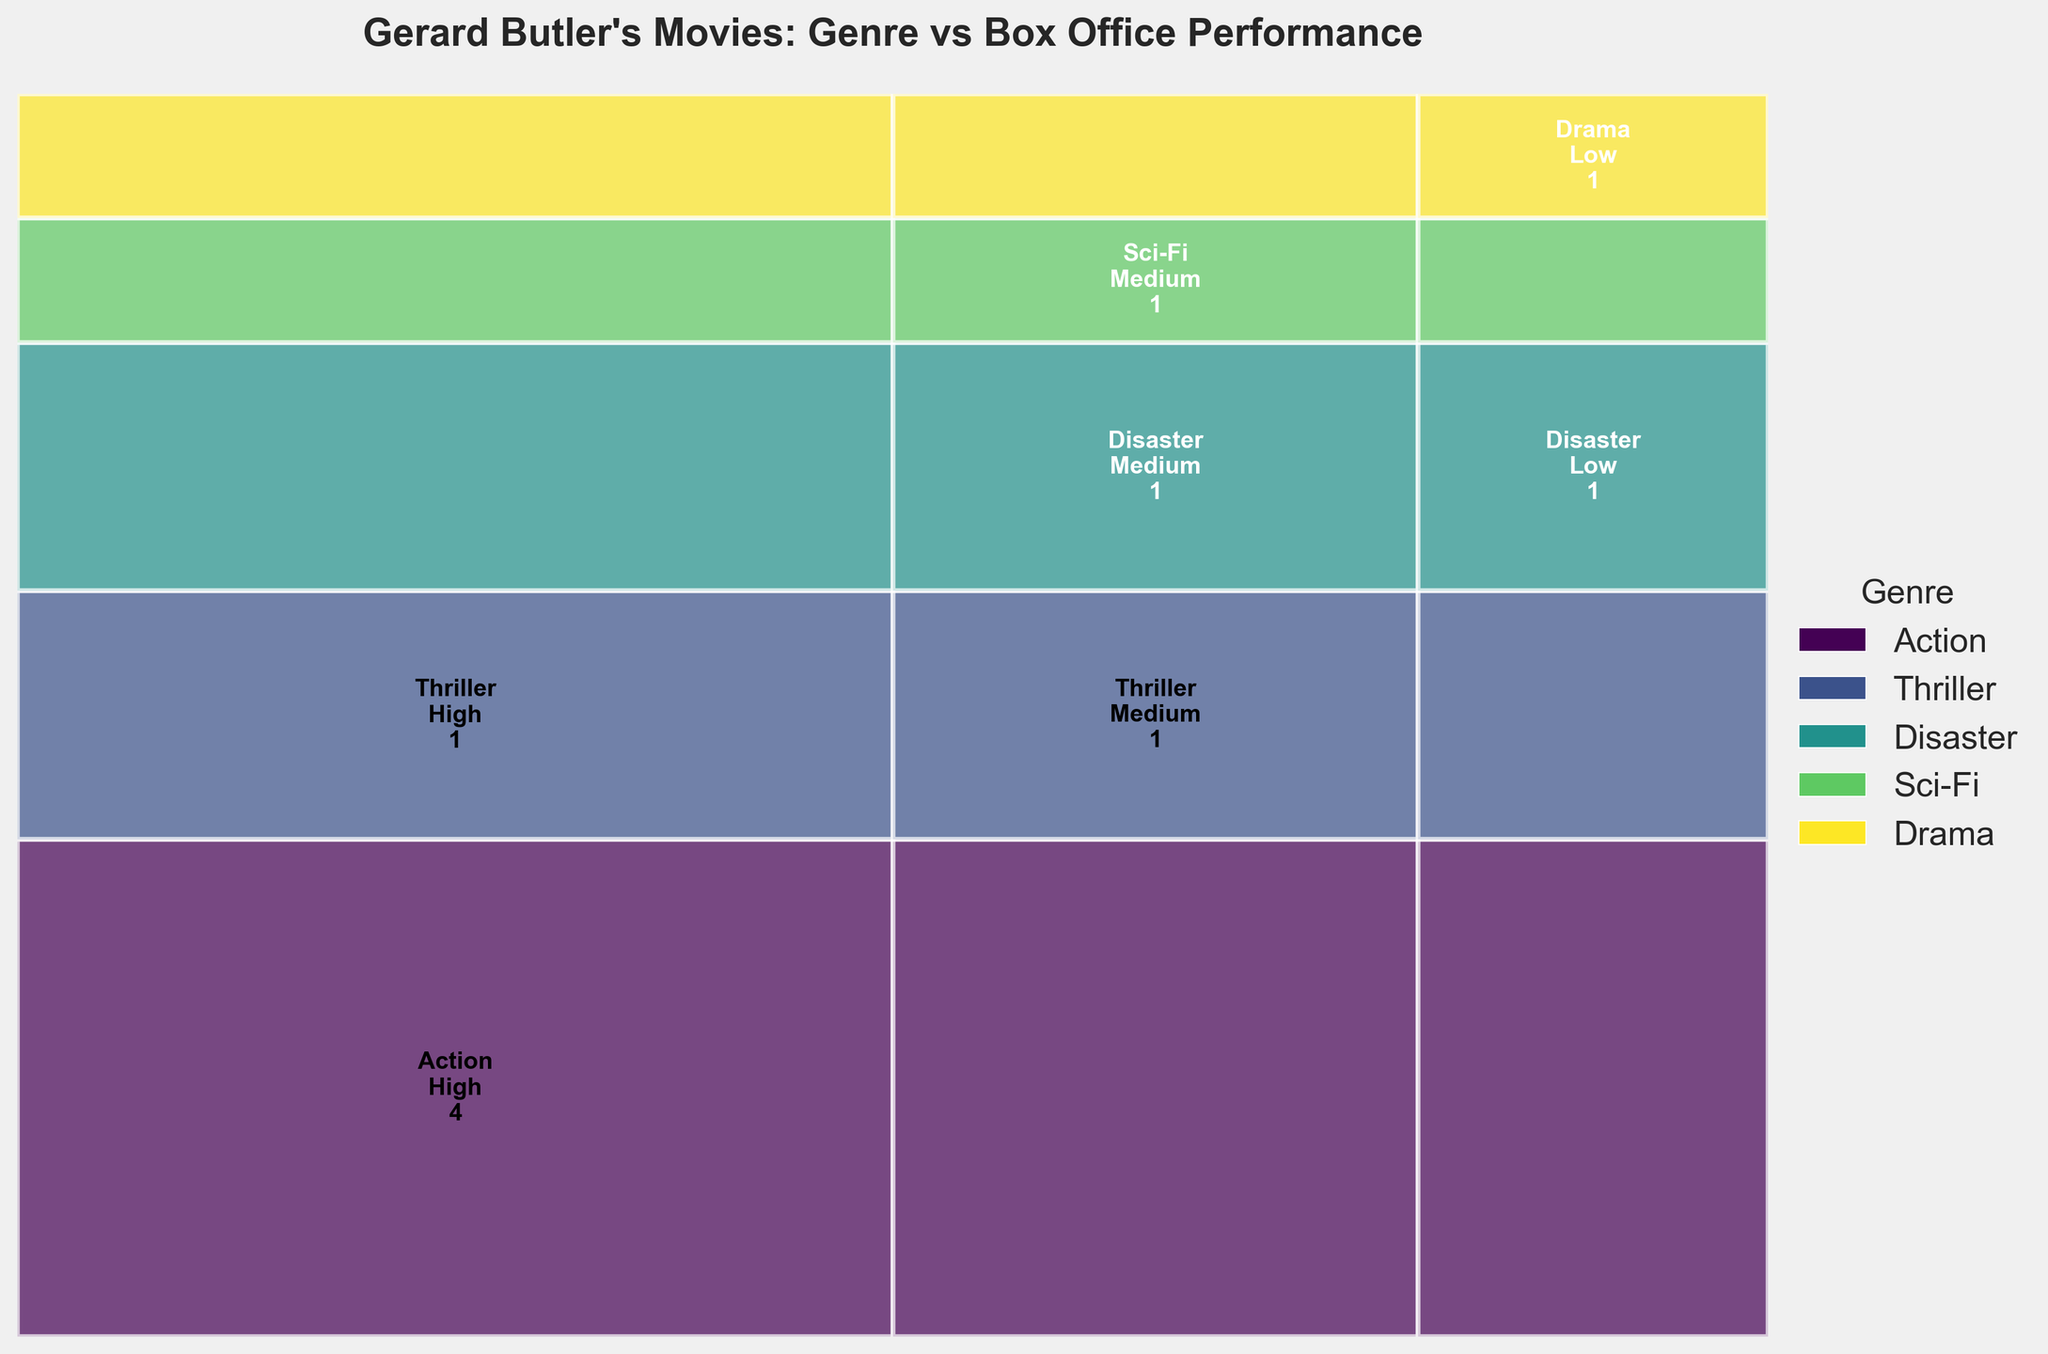How many Gerard Butler movies fall into the "High" box office range? To answer this, count the number of rectangles labeled "High" in the figure. The genres need not be considered, only the box office range.
Answer: 5 Which genre has the highest number of movies in the "Medium" box office range? Identify the genre with the largest rectangle labeled "Medium". The width of these rectangles will vary based on the count.
Answer: Thriller How many Action movies are there in total? Sum the number of Action movies in all three box office ranges. Look for all rectangles labeled "Action" and add up their counts.
Answer: 4 Which genre has the least representation in the "Low" box office range? Check the rectangles labeled "Low" for the smallest count. Compare each genre's count within this range to determine the least represented genre.
Answer: Drama Which box office range has the greatest overall number of movies? Identify the vertical segments corresponding to each box office range (High, Medium, Low) and sum the counts across all genres. The range with the highest total number is the answer.
Answer: High Which movie genre appears most frequently in the figure? Look at the color legend and compare the total width of each genre's rectangles across all box office ranges to determine which genre is represented the most.
Answer: Action Are there more Action movies in the "High" box office range or the "Medium" box office range? Compare the count of Action movies in the "High" range with those in the "Medium" range by checking the respective rectangles.
Answer: High What is the total number of movies in the "Disaster" genre? Add up the number of Disaster movies in all three box office ranges. Check the rectangles labeled "Disaster" and sum their counts.
Answer: 2 Which genre shows the greatest diversity in box office performance? Look for the genre that has movies in all three box office ranges (High, Medium, Low).
Answer: Action Between Sci-Fi and Drama genres, which has more movies in the figure? By counting the number of rectangles labeled "Sci-Fi" and "Drama", determine which genre has more total movies.
Answer: Sci-Fi 